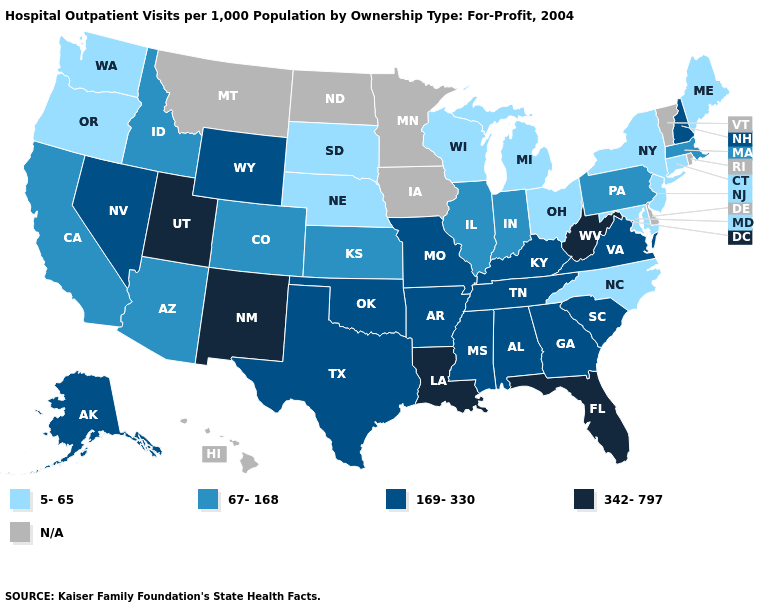Which states have the highest value in the USA?
Write a very short answer. Florida, Louisiana, New Mexico, Utah, West Virginia. Name the states that have a value in the range N/A?
Be succinct. Delaware, Hawaii, Iowa, Minnesota, Montana, North Dakota, Rhode Island, Vermont. What is the highest value in the West ?
Give a very brief answer. 342-797. What is the value of Utah?
Concise answer only. 342-797. Does the first symbol in the legend represent the smallest category?
Quick response, please. Yes. What is the value of Mississippi?
Be succinct. 169-330. What is the value of South Carolina?
Keep it brief. 169-330. Does New Mexico have the highest value in the USA?
Short answer required. Yes. What is the value of Oregon?
Quick response, please. 5-65. Does West Virginia have the highest value in the USA?
Answer briefly. Yes. Name the states that have a value in the range N/A?
Be succinct. Delaware, Hawaii, Iowa, Minnesota, Montana, North Dakota, Rhode Island, Vermont. What is the lowest value in the USA?
Quick response, please. 5-65. What is the highest value in states that border Wisconsin?
Answer briefly. 67-168. What is the lowest value in the MidWest?
Be succinct. 5-65. Does North Carolina have the lowest value in the USA?
Short answer required. Yes. 